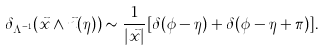Convert formula to latex. <formula><loc_0><loc_0><loc_500><loc_500>\delta _ { \Lambda ^ { - 1 } } ( \vec { x } \wedge \vec { n } ( \eta ) ) \sim \frac { 1 } { | \vec { x } | } [ \delta ( \phi - \eta ) + \delta ( \phi - \eta + \pi ) ] .</formula> 